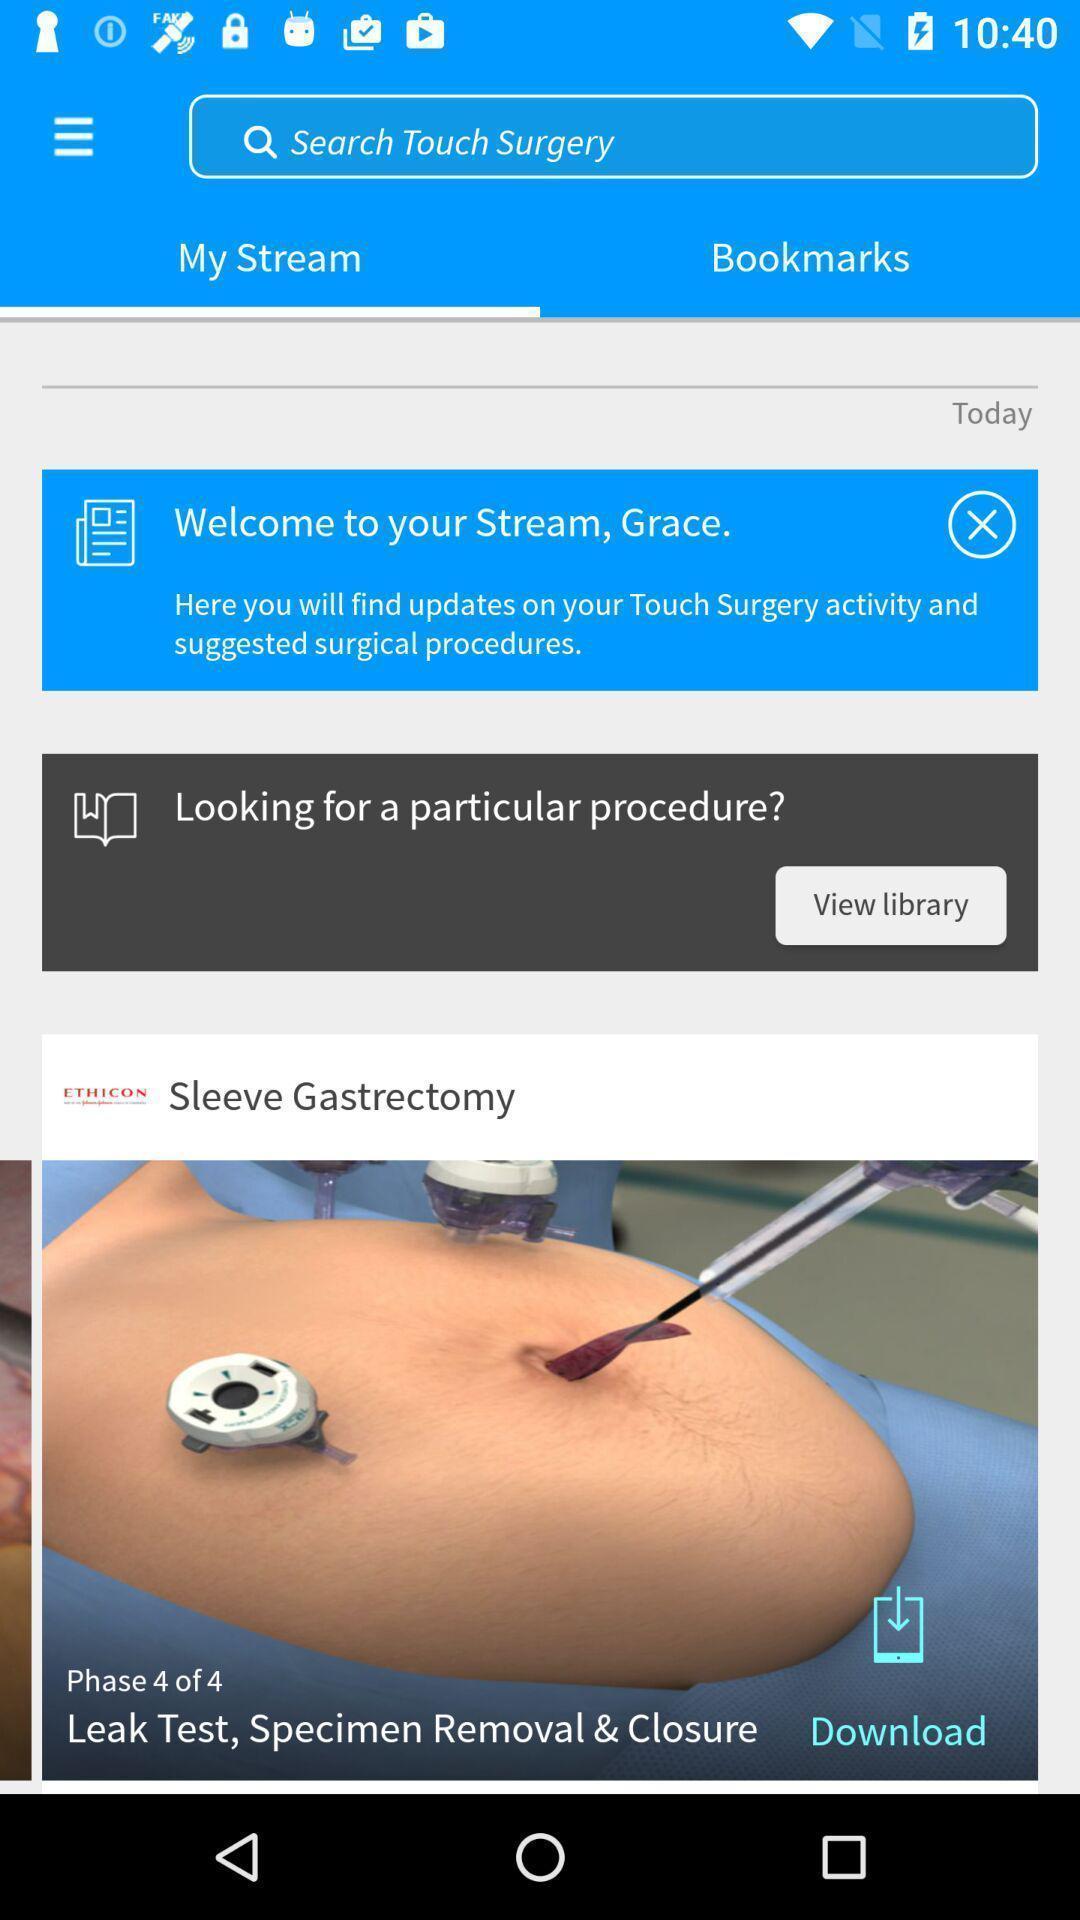Tell me about the visual elements in this screen capture. Screen displaying surgical information and a search bar. 